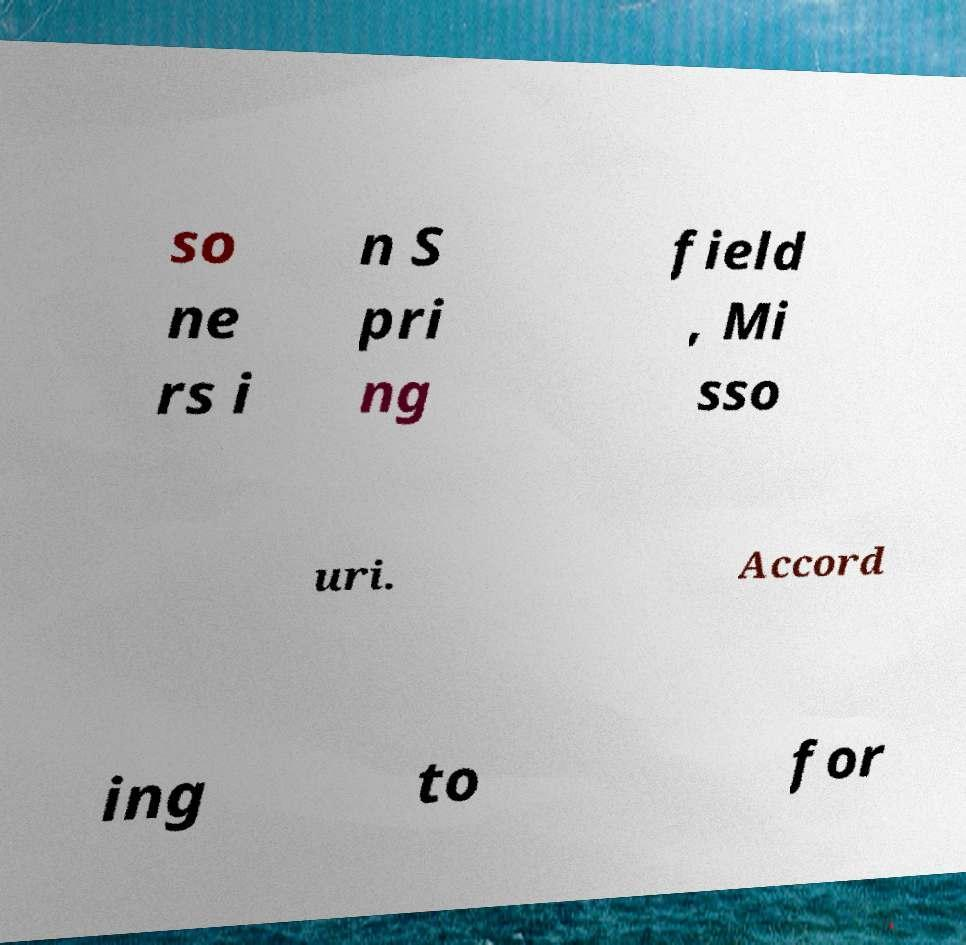Can you read and provide the text displayed in the image?This photo seems to have some interesting text. Can you extract and type it out for me? so ne rs i n S pri ng field , Mi sso uri. Accord ing to for 